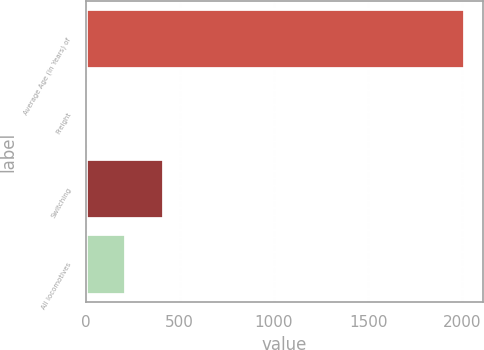Convert chart. <chart><loc_0><loc_0><loc_500><loc_500><bar_chart><fcel>Average Age (in Years) of<fcel>Freight<fcel>Switching<fcel>All locomotives<nl><fcel>2012<fcel>15.7<fcel>414.96<fcel>215.33<nl></chart> 